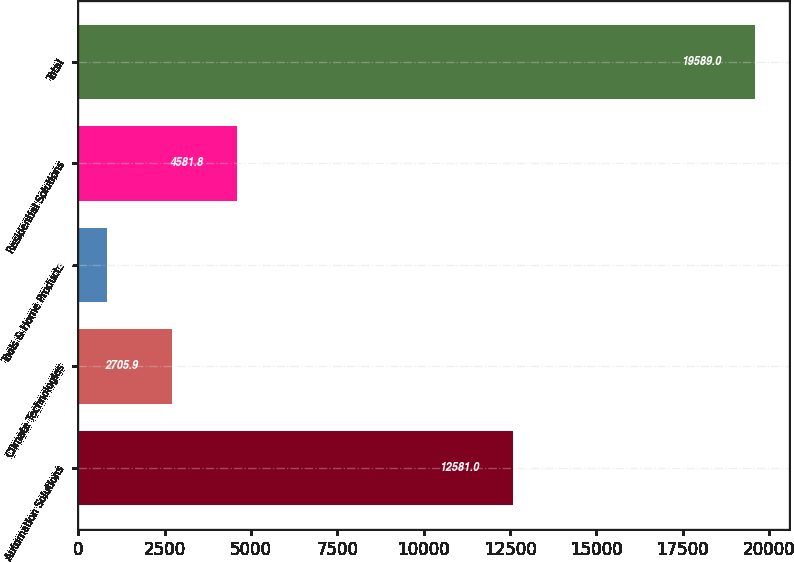Convert chart. <chart><loc_0><loc_0><loc_500><loc_500><bar_chart><fcel>Automation Solutions<fcel>Climate Technologies<fcel>Tools & Home Products<fcel>Residential Solutions<fcel>Total<nl><fcel>12581<fcel>2705.9<fcel>830<fcel>4581.8<fcel>19589<nl></chart> 